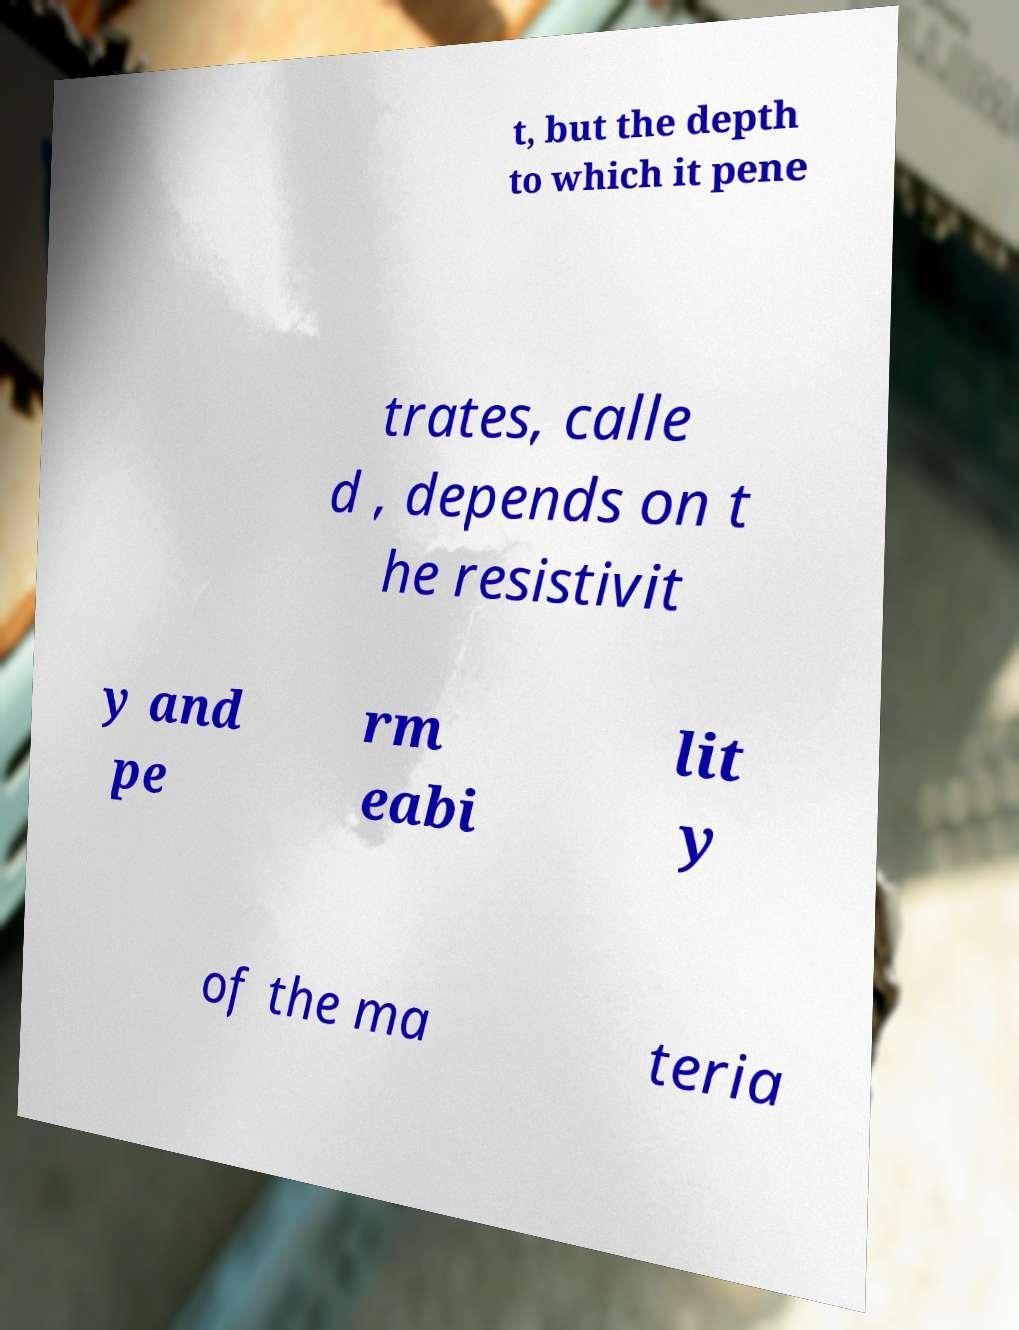For documentation purposes, I need the text within this image transcribed. Could you provide that? t, but the depth to which it pene trates, calle d , depends on t he resistivit y and pe rm eabi lit y of the ma teria 